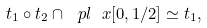<formula> <loc_0><loc_0><loc_500><loc_500>t _ { 1 } \circ t _ { 2 } \cap \ p l \ x [ 0 , 1 / 2 ] \simeq t _ { 1 } ,</formula> 